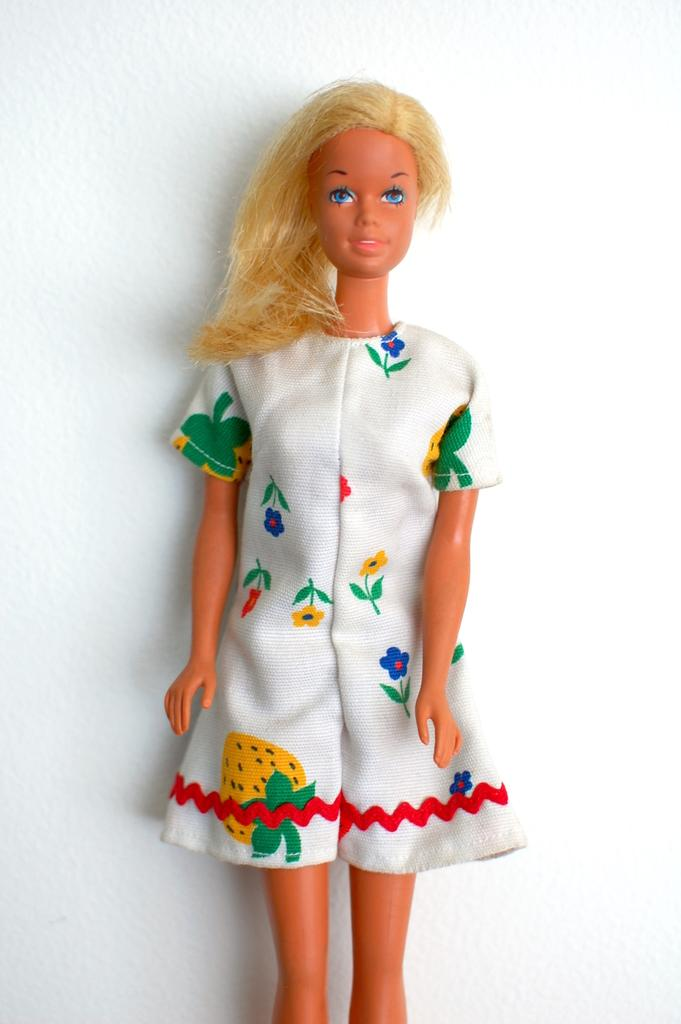What is the main subject in the center of the image? There is a doll in the center of the image. What can be seen in the background of the image? There is a wall in the background of the image. How many clams are sitting on the wall in the image? There are no clams present in the image; it features a doll and a wall. What type of ring can be seen on the doll's finger in the image? The doll in the image does not have a ring on its finger. 